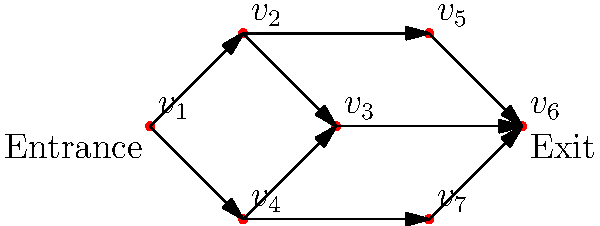In the directed graph representing traffic flow in a shopping mall, where $v_1$ is the entrance and $v_6$ is the exit, how many different paths can a shopper take from the entrance to the exit? To solve this problem, we need to count the number of distinct paths from $v_1$ to $v_6$. Let's break it down step-by-step:

1. From $v_1$, we have two initial options:
   a. $v_1 \to v_2$
   b. $v_1 \to v_4$

2. If we choose $v_1 \to v_2$:
   - We can go directly to $v_3$, then to $v_6$
   - Or we can go to $v_5$, then to $v_6$
   This gives us 2 paths: $v_1 \to v_2 \to v_3 \to v_6$ and $v_1 \to v_2 \to v_5 \to v_6$

3. If we choose $v_1 \to v_4$:
   - We can go to $v_3$, then to $v_6$
   - Or we can go to $v_7$, then to $v_6$
   - Or we can go to $v_5$, then to $v_6$
   This gives us 3 paths: $v_1 \to v_4 \to v_3 \to v_6$, $v_1 \to v_4 \to v_7 \to v_6$, and $v_1 \to v_4 \to v_5 \to v_6$

4. Adding up all possible paths:
   2 paths from $v_1 \to v_2$ + 3 paths from $v_1 \to v_4$ = 5 total paths

Therefore, there are 5 different paths a shopper can take from the entrance to the exit.
Answer: 5 paths 